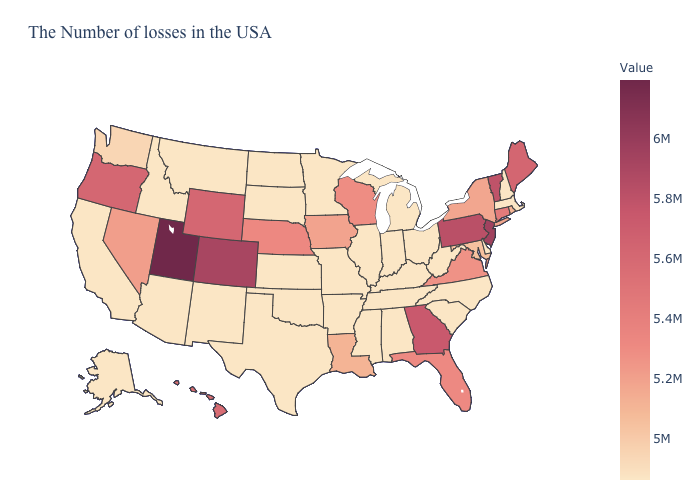Which states have the lowest value in the USA?
Concise answer only. Massachusetts, New Hampshire, Delaware, North Carolina, South Carolina, West Virginia, Ohio, Michigan, Kentucky, Indiana, Alabama, Tennessee, Illinois, Mississippi, Missouri, Arkansas, Minnesota, Kansas, Oklahoma, Texas, South Dakota, North Dakota, New Mexico, Montana, Arizona, Idaho, California, Alaska. Which states have the lowest value in the MidWest?
Write a very short answer. Ohio, Michigan, Indiana, Illinois, Missouri, Minnesota, Kansas, South Dakota, North Dakota. Does New Jersey have the highest value in the USA?
Keep it brief. No. Among the states that border Wisconsin , which have the highest value?
Give a very brief answer. Iowa. Among the states that border Oregon , which have the lowest value?
Be succinct. Idaho, California. Among the states that border Wisconsin , which have the lowest value?
Keep it brief. Michigan, Illinois, Minnesota. 